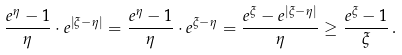Convert formula to latex. <formula><loc_0><loc_0><loc_500><loc_500>\frac { e ^ { \eta } - 1 } { \eta } \cdot e ^ { | \xi - \eta | } = \frac { e ^ { \eta } - 1 } { \eta } \cdot e ^ { \xi - \eta } = \frac { e ^ { \xi } - e ^ { | \xi - \eta | } } { \eta } \geq \frac { e ^ { \xi } - 1 } { \xi } \, .</formula> 